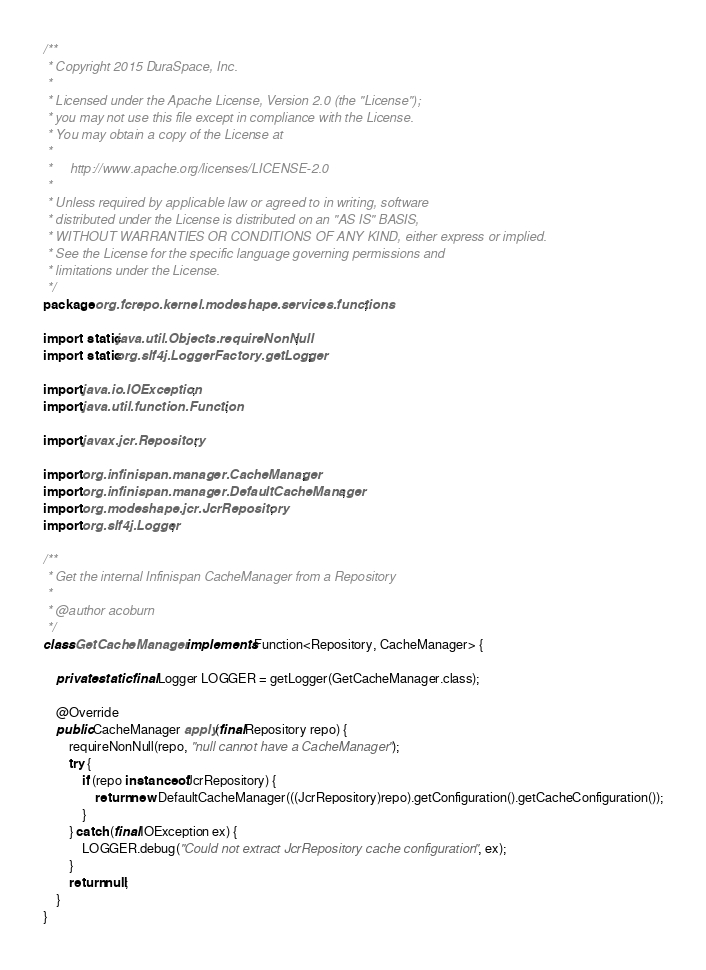<code> <loc_0><loc_0><loc_500><loc_500><_Java_>/**
 * Copyright 2015 DuraSpace, Inc.
 *
 * Licensed under the Apache License, Version 2.0 (the "License");
 * you may not use this file except in compliance with the License.
 * You may obtain a copy of the License at
 *
 *     http://www.apache.org/licenses/LICENSE-2.0
 *
 * Unless required by applicable law or agreed to in writing, software
 * distributed under the License is distributed on an "AS IS" BASIS,
 * WITHOUT WARRANTIES OR CONDITIONS OF ANY KIND, either express or implied.
 * See the License for the specific language governing permissions and
 * limitations under the License.
 */
package org.fcrepo.kernel.modeshape.services.functions;

import static java.util.Objects.requireNonNull;
import static org.slf4j.LoggerFactory.getLogger;

import java.io.IOException;
import java.util.function.Function;

import javax.jcr.Repository;

import org.infinispan.manager.CacheManager;
import org.infinispan.manager.DefaultCacheManager;
import org.modeshape.jcr.JcrRepository;
import org.slf4j.Logger;

/**
 * Get the internal Infinispan CacheManager from a Repository
 *
 * @author acoburn
 */
class GetCacheManager implements Function<Repository, CacheManager> {

    private static final Logger LOGGER = getLogger(GetCacheManager.class);

    @Override
    public CacheManager apply(final Repository repo) {
        requireNonNull(repo, "null cannot have a CacheManager");
        try {
            if (repo instanceof JcrRepository) {
                return new DefaultCacheManager(((JcrRepository)repo).getConfiguration().getCacheConfiguration());
            }
        } catch (final IOException ex) {
            LOGGER.debug("Could not extract JcrRepository cache configuration", ex);
        }
        return null;
    }
}

</code> 